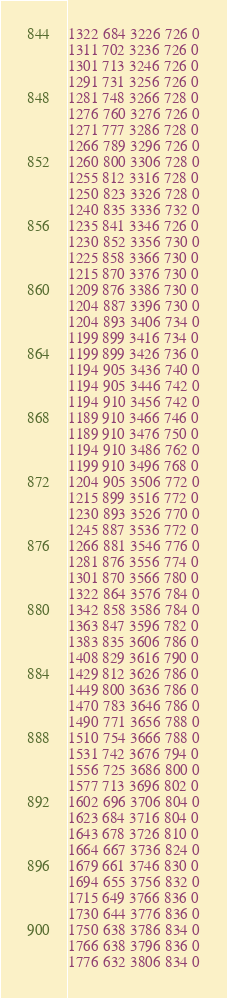<code> <loc_0><loc_0><loc_500><loc_500><_SML_>1322 684 3226 726 0
1311 702 3236 726 0
1301 713 3246 726 0
1291 731 3256 726 0
1281 748 3266 728 0
1276 760 3276 726 0
1271 777 3286 728 0
1266 789 3296 726 0
1260 800 3306 728 0
1255 812 3316 728 0
1250 823 3326 728 0
1240 835 3336 732 0
1235 841 3346 726 0
1230 852 3356 730 0
1225 858 3366 730 0
1215 870 3376 730 0
1209 876 3386 730 0
1204 887 3396 730 0
1204 893 3406 734 0
1199 899 3416 734 0
1199 899 3426 736 0
1194 905 3436 740 0
1194 905 3446 742 0
1194 910 3456 742 0
1189 910 3466 746 0
1189 910 3476 750 0
1194 910 3486 762 0
1199 910 3496 768 0
1204 905 3506 772 0
1215 899 3516 772 0
1230 893 3526 770 0
1245 887 3536 772 0
1266 881 3546 776 0
1281 876 3556 774 0
1301 870 3566 780 0
1322 864 3576 784 0
1342 858 3586 784 0
1363 847 3596 782 0
1383 835 3606 786 0
1408 829 3616 790 0
1429 812 3626 786 0
1449 800 3636 786 0
1470 783 3646 786 0
1490 771 3656 788 0
1510 754 3666 788 0
1531 742 3676 794 0
1556 725 3686 800 0
1577 713 3696 802 0
1602 696 3706 804 0
1623 684 3716 804 0
1643 678 3726 810 0
1664 667 3736 824 0
1679 661 3746 830 0
1694 655 3756 832 0
1715 649 3766 836 0
1730 644 3776 836 0
1750 638 3786 834 0
1766 638 3796 836 0
1776 632 3806 834 0</code> 